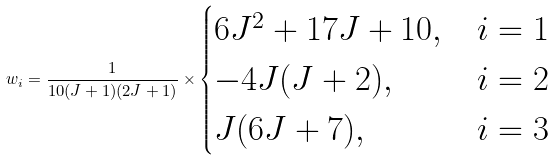Convert formula to latex. <formula><loc_0><loc_0><loc_500><loc_500>w _ { i } = \frac { 1 } { 1 0 ( J + 1 ) ( 2 J + 1 ) } \times \begin{cases} 6 J ^ { 2 } + 1 7 J + 1 0 , & i = 1 \\ - 4 J ( J + 2 ) , & i = 2 \\ J ( 6 J + 7 ) , & i = 3 \end{cases}</formula> 